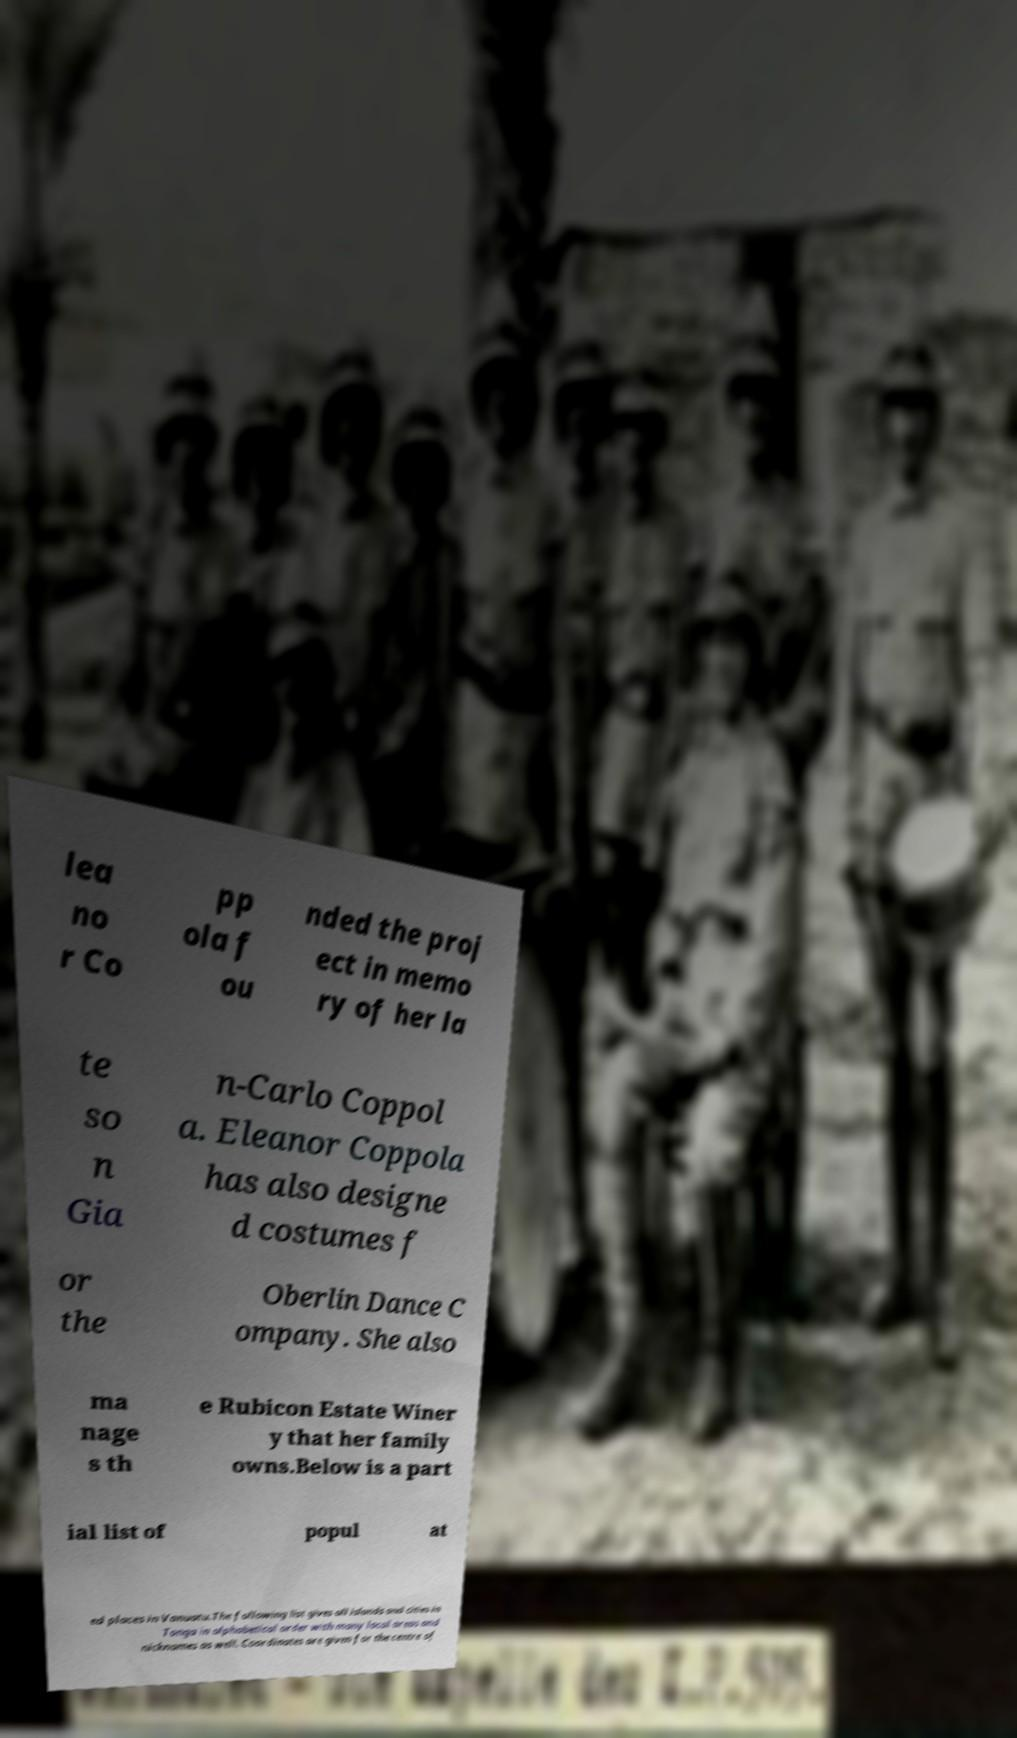What messages or text are displayed in this image? I need them in a readable, typed format. lea no r Co pp ola f ou nded the proj ect in memo ry of her la te so n Gia n-Carlo Coppol a. Eleanor Coppola has also designe d costumes f or the Oberlin Dance C ompany. She also ma nage s th e Rubicon Estate Winer y that her family owns.Below is a part ial list of popul at ed places in Vanuatu.The following list gives all islands and cities in Tonga in alphabetical order with many local areas and nicknames as well. Coordinates are given for the centre of 